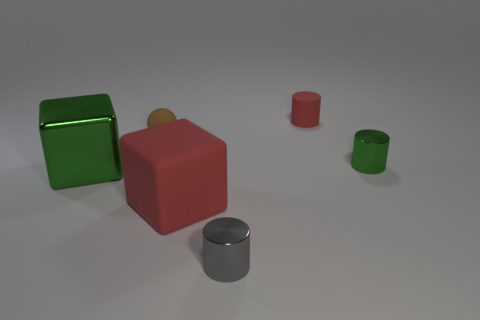There is a metallic object that is the same size as the red block; what color is it?
Your answer should be compact. Green. Are there any rubber cylinders that have the same color as the matte ball?
Give a very brief answer. No. Is there a tiny thing?
Offer a very short reply. Yes. Do the green thing that is left of the red cylinder and the tiny gray cylinder have the same material?
Offer a very short reply. Yes. What is the size of the other object that is the same color as the large rubber thing?
Provide a short and direct response. Small. How many red cubes have the same size as the ball?
Your answer should be very brief. 0. Are there the same number of gray metallic objects left of the small gray shiny cylinder and cubes?
Give a very brief answer. No. What number of green things are both to the left of the large red matte cube and to the right of the tiny red matte cylinder?
Provide a succinct answer. 0. There is a red cube that is the same material as the small ball; what is its size?
Make the answer very short. Large. What number of gray metallic objects have the same shape as the big matte thing?
Keep it short and to the point. 0. 